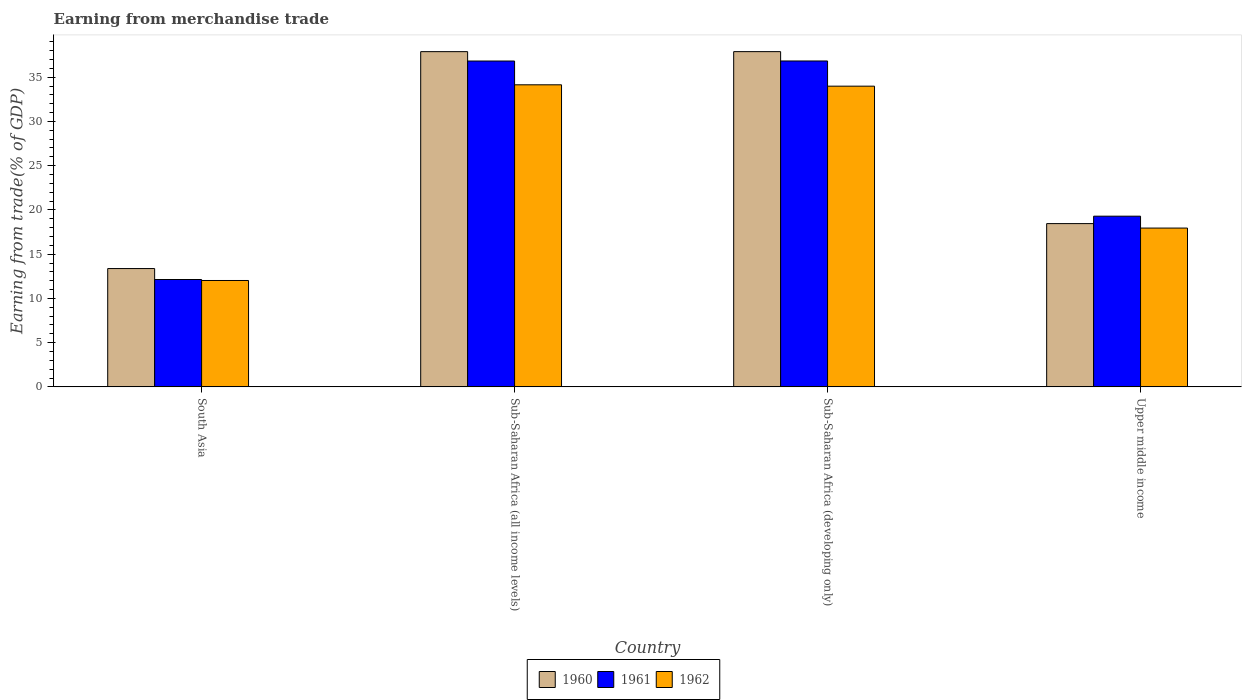What is the label of the 3rd group of bars from the left?
Your answer should be very brief. Sub-Saharan Africa (developing only). In how many cases, is the number of bars for a given country not equal to the number of legend labels?
Keep it short and to the point. 0. What is the earnings from trade in 1961 in South Asia?
Make the answer very short. 12.14. Across all countries, what is the maximum earnings from trade in 1962?
Provide a succinct answer. 34.14. Across all countries, what is the minimum earnings from trade in 1960?
Your response must be concise. 13.37. In which country was the earnings from trade in 1961 maximum?
Keep it short and to the point. Sub-Saharan Africa (developing only). In which country was the earnings from trade in 1961 minimum?
Offer a terse response. South Asia. What is the total earnings from trade in 1961 in the graph?
Give a very brief answer. 105.09. What is the difference between the earnings from trade in 1960 in Sub-Saharan Africa (all income levels) and that in Upper middle income?
Make the answer very short. 19.43. What is the difference between the earnings from trade in 1960 in Upper middle income and the earnings from trade in 1961 in Sub-Saharan Africa (developing only)?
Your answer should be very brief. -18.38. What is the average earnings from trade in 1962 per country?
Offer a very short reply. 24.53. What is the difference between the earnings from trade of/in 1961 and earnings from trade of/in 1962 in Sub-Saharan Africa (all income levels)?
Your answer should be very brief. 2.69. What is the ratio of the earnings from trade in 1960 in Sub-Saharan Africa (all income levels) to that in Sub-Saharan Africa (developing only)?
Your response must be concise. 1. Is the earnings from trade in 1962 in South Asia less than that in Sub-Saharan Africa (developing only)?
Provide a short and direct response. Yes. What is the difference between the highest and the second highest earnings from trade in 1960?
Your response must be concise. -19.43. What is the difference between the highest and the lowest earnings from trade in 1962?
Your answer should be compact. 22.12. In how many countries, is the earnings from trade in 1960 greater than the average earnings from trade in 1960 taken over all countries?
Make the answer very short. 2. Is the sum of the earnings from trade in 1962 in Sub-Saharan Africa (all income levels) and Upper middle income greater than the maximum earnings from trade in 1960 across all countries?
Provide a succinct answer. Yes. What does the 2nd bar from the right in Upper middle income represents?
Offer a terse response. 1961. Is it the case that in every country, the sum of the earnings from trade in 1960 and earnings from trade in 1961 is greater than the earnings from trade in 1962?
Your answer should be compact. Yes. How many bars are there?
Your response must be concise. 12. How many countries are there in the graph?
Offer a terse response. 4. Are the values on the major ticks of Y-axis written in scientific E-notation?
Provide a succinct answer. No. What is the title of the graph?
Your response must be concise. Earning from merchandise trade. What is the label or title of the X-axis?
Offer a terse response. Country. What is the label or title of the Y-axis?
Ensure brevity in your answer.  Earning from trade(% of GDP). What is the Earning from trade(% of GDP) in 1960 in South Asia?
Provide a succinct answer. 13.37. What is the Earning from trade(% of GDP) in 1961 in South Asia?
Provide a succinct answer. 12.14. What is the Earning from trade(% of GDP) in 1962 in South Asia?
Give a very brief answer. 12.02. What is the Earning from trade(% of GDP) in 1960 in Sub-Saharan Africa (all income levels)?
Your answer should be very brief. 37.89. What is the Earning from trade(% of GDP) in 1961 in Sub-Saharan Africa (all income levels)?
Make the answer very short. 36.83. What is the Earning from trade(% of GDP) of 1962 in Sub-Saharan Africa (all income levels)?
Your answer should be very brief. 34.14. What is the Earning from trade(% of GDP) in 1960 in Sub-Saharan Africa (developing only)?
Keep it short and to the point. 37.89. What is the Earning from trade(% of GDP) in 1961 in Sub-Saharan Africa (developing only)?
Offer a terse response. 36.84. What is the Earning from trade(% of GDP) in 1962 in Sub-Saharan Africa (developing only)?
Provide a short and direct response. 33.99. What is the Earning from trade(% of GDP) in 1960 in Upper middle income?
Ensure brevity in your answer.  18.45. What is the Earning from trade(% of GDP) in 1961 in Upper middle income?
Keep it short and to the point. 19.29. What is the Earning from trade(% of GDP) in 1962 in Upper middle income?
Provide a short and direct response. 17.95. Across all countries, what is the maximum Earning from trade(% of GDP) in 1960?
Your answer should be compact. 37.89. Across all countries, what is the maximum Earning from trade(% of GDP) in 1961?
Give a very brief answer. 36.84. Across all countries, what is the maximum Earning from trade(% of GDP) of 1962?
Your response must be concise. 34.14. Across all countries, what is the minimum Earning from trade(% of GDP) in 1960?
Your answer should be very brief. 13.37. Across all countries, what is the minimum Earning from trade(% of GDP) in 1961?
Provide a succinct answer. 12.14. Across all countries, what is the minimum Earning from trade(% of GDP) of 1962?
Make the answer very short. 12.02. What is the total Earning from trade(% of GDP) of 1960 in the graph?
Make the answer very short. 107.61. What is the total Earning from trade(% of GDP) in 1961 in the graph?
Your answer should be very brief. 105.09. What is the total Earning from trade(% of GDP) in 1962 in the graph?
Keep it short and to the point. 98.1. What is the difference between the Earning from trade(% of GDP) of 1960 in South Asia and that in Sub-Saharan Africa (all income levels)?
Offer a very short reply. -24.52. What is the difference between the Earning from trade(% of GDP) in 1961 in South Asia and that in Sub-Saharan Africa (all income levels)?
Provide a short and direct response. -24.7. What is the difference between the Earning from trade(% of GDP) in 1962 in South Asia and that in Sub-Saharan Africa (all income levels)?
Your answer should be very brief. -22.12. What is the difference between the Earning from trade(% of GDP) in 1960 in South Asia and that in Sub-Saharan Africa (developing only)?
Provide a succinct answer. -24.52. What is the difference between the Earning from trade(% of GDP) in 1961 in South Asia and that in Sub-Saharan Africa (developing only)?
Provide a succinct answer. -24.7. What is the difference between the Earning from trade(% of GDP) of 1962 in South Asia and that in Sub-Saharan Africa (developing only)?
Offer a terse response. -21.96. What is the difference between the Earning from trade(% of GDP) of 1960 in South Asia and that in Upper middle income?
Ensure brevity in your answer.  -5.08. What is the difference between the Earning from trade(% of GDP) in 1961 in South Asia and that in Upper middle income?
Give a very brief answer. -7.16. What is the difference between the Earning from trade(% of GDP) of 1962 in South Asia and that in Upper middle income?
Provide a short and direct response. -5.92. What is the difference between the Earning from trade(% of GDP) in 1960 in Sub-Saharan Africa (all income levels) and that in Sub-Saharan Africa (developing only)?
Your response must be concise. -0. What is the difference between the Earning from trade(% of GDP) in 1961 in Sub-Saharan Africa (all income levels) and that in Sub-Saharan Africa (developing only)?
Your response must be concise. -0. What is the difference between the Earning from trade(% of GDP) of 1962 in Sub-Saharan Africa (all income levels) and that in Sub-Saharan Africa (developing only)?
Your response must be concise. 0.15. What is the difference between the Earning from trade(% of GDP) in 1960 in Sub-Saharan Africa (all income levels) and that in Upper middle income?
Keep it short and to the point. 19.43. What is the difference between the Earning from trade(% of GDP) of 1961 in Sub-Saharan Africa (all income levels) and that in Upper middle income?
Give a very brief answer. 17.54. What is the difference between the Earning from trade(% of GDP) of 1962 in Sub-Saharan Africa (all income levels) and that in Upper middle income?
Offer a very short reply. 16.19. What is the difference between the Earning from trade(% of GDP) of 1960 in Sub-Saharan Africa (developing only) and that in Upper middle income?
Your answer should be very brief. 19.44. What is the difference between the Earning from trade(% of GDP) in 1961 in Sub-Saharan Africa (developing only) and that in Upper middle income?
Ensure brevity in your answer.  17.54. What is the difference between the Earning from trade(% of GDP) of 1962 in Sub-Saharan Africa (developing only) and that in Upper middle income?
Make the answer very short. 16.04. What is the difference between the Earning from trade(% of GDP) of 1960 in South Asia and the Earning from trade(% of GDP) of 1961 in Sub-Saharan Africa (all income levels)?
Provide a short and direct response. -23.46. What is the difference between the Earning from trade(% of GDP) in 1960 in South Asia and the Earning from trade(% of GDP) in 1962 in Sub-Saharan Africa (all income levels)?
Keep it short and to the point. -20.77. What is the difference between the Earning from trade(% of GDP) of 1961 in South Asia and the Earning from trade(% of GDP) of 1962 in Sub-Saharan Africa (all income levels)?
Your answer should be very brief. -22.01. What is the difference between the Earning from trade(% of GDP) in 1960 in South Asia and the Earning from trade(% of GDP) in 1961 in Sub-Saharan Africa (developing only)?
Make the answer very short. -23.46. What is the difference between the Earning from trade(% of GDP) of 1960 in South Asia and the Earning from trade(% of GDP) of 1962 in Sub-Saharan Africa (developing only)?
Offer a very short reply. -20.62. What is the difference between the Earning from trade(% of GDP) in 1961 in South Asia and the Earning from trade(% of GDP) in 1962 in Sub-Saharan Africa (developing only)?
Your answer should be compact. -21.85. What is the difference between the Earning from trade(% of GDP) in 1960 in South Asia and the Earning from trade(% of GDP) in 1961 in Upper middle income?
Ensure brevity in your answer.  -5.92. What is the difference between the Earning from trade(% of GDP) of 1960 in South Asia and the Earning from trade(% of GDP) of 1962 in Upper middle income?
Keep it short and to the point. -4.58. What is the difference between the Earning from trade(% of GDP) in 1961 in South Asia and the Earning from trade(% of GDP) in 1962 in Upper middle income?
Keep it short and to the point. -5.81. What is the difference between the Earning from trade(% of GDP) of 1960 in Sub-Saharan Africa (all income levels) and the Earning from trade(% of GDP) of 1961 in Sub-Saharan Africa (developing only)?
Ensure brevity in your answer.  1.05. What is the difference between the Earning from trade(% of GDP) in 1960 in Sub-Saharan Africa (all income levels) and the Earning from trade(% of GDP) in 1962 in Sub-Saharan Africa (developing only)?
Give a very brief answer. 3.9. What is the difference between the Earning from trade(% of GDP) of 1961 in Sub-Saharan Africa (all income levels) and the Earning from trade(% of GDP) of 1962 in Sub-Saharan Africa (developing only)?
Offer a very short reply. 2.84. What is the difference between the Earning from trade(% of GDP) in 1960 in Sub-Saharan Africa (all income levels) and the Earning from trade(% of GDP) in 1961 in Upper middle income?
Make the answer very short. 18.6. What is the difference between the Earning from trade(% of GDP) of 1960 in Sub-Saharan Africa (all income levels) and the Earning from trade(% of GDP) of 1962 in Upper middle income?
Provide a short and direct response. 19.94. What is the difference between the Earning from trade(% of GDP) of 1961 in Sub-Saharan Africa (all income levels) and the Earning from trade(% of GDP) of 1962 in Upper middle income?
Make the answer very short. 18.88. What is the difference between the Earning from trade(% of GDP) in 1960 in Sub-Saharan Africa (developing only) and the Earning from trade(% of GDP) in 1961 in Upper middle income?
Ensure brevity in your answer.  18.6. What is the difference between the Earning from trade(% of GDP) in 1960 in Sub-Saharan Africa (developing only) and the Earning from trade(% of GDP) in 1962 in Upper middle income?
Make the answer very short. 19.94. What is the difference between the Earning from trade(% of GDP) in 1961 in Sub-Saharan Africa (developing only) and the Earning from trade(% of GDP) in 1962 in Upper middle income?
Provide a succinct answer. 18.89. What is the average Earning from trade(% of GDP) in 1960 per country?
Your response must be concise. 26.9. What is the average Earning from trade(% of GDP) in 1961 per country?
Provide a short and direct response. 26.27. What is the average Earning from trade(% of GDP) of 1962 per country?
Offer a terse response. 24.53. What is the difference between the Earning from trade(% of GDP) in 1960 and Earning from trade(% of GDP) in 1961 in South Asia?
Ensure brevity in your answer.  1.24. What is the difference between the Earning from trade(% of GDP) in 1960 and Earning from trade(% of GDP) in 1962 in South Asia?
Give a very brief answer. 1.35. What is the difference between the Earning from trade(% of GDP) of 1961 and Earning from trade(% of GDP) of 1962 in South Asia?
Offer a terse response. 0.11. What is the difference between the Earning from trade(% of GDP) of 1960 and Earning from trade(% of GDP) of 1961 in Sub-Saharan Africa (all income levels)?
Provide a short and direct response. 1.06. What is the difference between the Earning from trade(% of GDP) of 1960 and Earning from trade(% of GDP) of 1962 in Sub-Saharan Africa (all income levels)?
Provide a succinct answer. 3.75. What is the difference between the Earning from trade(% of GDP) in 1961 and Earning from trade(% of GDP) in 1962 in Sub-Saharan Africa (all income levels)?
Your response must be concise. 2.69. What is the difference between the Earning from trade(% of GDP) of 1960 and Earning from trade(% of GDP) of 1961 in Sub-Saharan Africa (developing only)?
Your answer should be very brief. 1.06. What is the difference between the Earning from trade(% of GDP) in 1960 and Earning from trade(% of GDP) in 1962 in Sub-Saharan Africa (developing only)?
Provide a succinct answer. 3.9. What is the difference between the Earning from trade(% of GDP) in 1961 and Earning from trade(% of GDP) in 1962 in Sub-Saharan Africa (developing only)?
Make the answer very short. 2.85. What is the difference between the Earning from trade(% of GDP) of 1960 and Earning from trade(% of GDP) of 1961 in Upper middle income?
Keep it short and to the point. -0.84. What is the difference between the Earning from trade(% of GDP) in 1960 and Earning from trade(% of GDP) in 1962 in Upper middle income?
Your answer should be very brief. 0.51. What is the difference between the Earning from trade(% of GDP) of 1961 and Earning from trade(% of GDP) of 1962 in Upper middle income?
Offer a very short reply. 1.34. What is the ratio of the Earning from trade(% of GDP) of 1960 in South Asia to that in Sub-Saharan Africa (all income levels)?
Provide a short and direct response. 0.35. What is the ratio of the Earning from trade(% of GDP) of 1961 in South Asia to that in Sub-Saharan Africa (all income levels)?
Provide a succinct answer. 0.33. What is the ratio of the Earning from trade(% of GDP) in 1962 in South Asia to that in Sub-Saharan Africa (all income levels)?
Keep it short and to the point. 0.35. What is the ratio of the Earning from trade(% of GDP) in 1960 in South Asia to that in Sub-Saharan Africa (developing only)?
Offer a very short reply. 0.35. What is the ratio of the Earning from trade(% of GDP) in 1961 in South Asia to that in Sub-Saharan Africa (developing only)?
Make the answer very short. 0.33. What is the ratio of the Earning from trade(% of GDP) in 1962 in South Asia to that in Sub-Saharan Africa (developing only)?
Your response must be concise. 0.35. What is the ratio of the Earning from trade(% of GDP) of 1960 in South Asia to that in Upper middle income?
Offer a terse response. 0.72. What is the ratio of the Earning from trade(% of GDP) in 1961 in South Asia to that in Upper middle income?
Your response must be concise. 0.63. What is the ratio of the Earning from trade(% of GDP) in 1962 in South Asia to that in Upper middle income?
Your answer should be very brief. 0.67. What is the ratio of the Earning from trade(% of GDP) of 1962 in Sub-Saharan Africa (all income levels) to that in Sub-Saharan Africa (developing only)?
Ensure brevity in your answer.  1. What is the ratio of the Earning from trade(% of GDP) of 1960 in Sub-Saharan Africa (all income levels) to that in Upper middle income?
Your answer should be very brief. 2.05. What is the ratio of the Earning from trade(% of GDP) in 1961 in Sub-Saharan Africa (all income levels) to that in Upper middle income?
Give a very brief answer. 1.91. What is the ratio of the Earning from trade(% of GDP) of 1962 in Sub-Saharan Africa (all income levels) to that in Upper middle income?
Make the answer very short. 1.9. What is the ratio of the Earning from trade(% of GDP) of 1960 in Sub-Saharan Africa (developing only) to that in Upper middle income?
Your answer should be compact. 2.05. What is the ratio of the Earning from trade(% of GDP) of 1961 in Sub-Saharan Africa (developing only) to that in Upper middle income?
Your answer should be compact. 1.91. What is the ratio of the Earning from trade(% of GDP) in 1962 in Sub-Saharan Africa (developing only) to that in Upper middle income?
Your response must be concise. 1.89. What is the difference between the highest and the second highest Earning from trade(% of GDP) in 1960?
Your response must be concise. 0. What is the difference between the highest and the second highest Earning from trade(% of GDP) of 1961?
Provide a short and direct response. 0. What is the difference between the highest and the second highest Earning from trade(% of GDP) in 1962?
Your answer should be very brief. 0.15. What is the difference between the highest and the lowest Earning from trade(% of GDP) in 1960?
Offer a terse response. 24.52. What is the difference between the highest and the lowest Earning from trade(% of GDP) of 1961?
Ensure brevity in your answer.  24.7. What is the difference between the highest and the lowest Earning from trade(% of GDP) of 1962?
Your response must be concise. 22.12. 